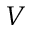<formula> <loc_0><loc_0><loc_500><loc_500>{ V }</formula> 